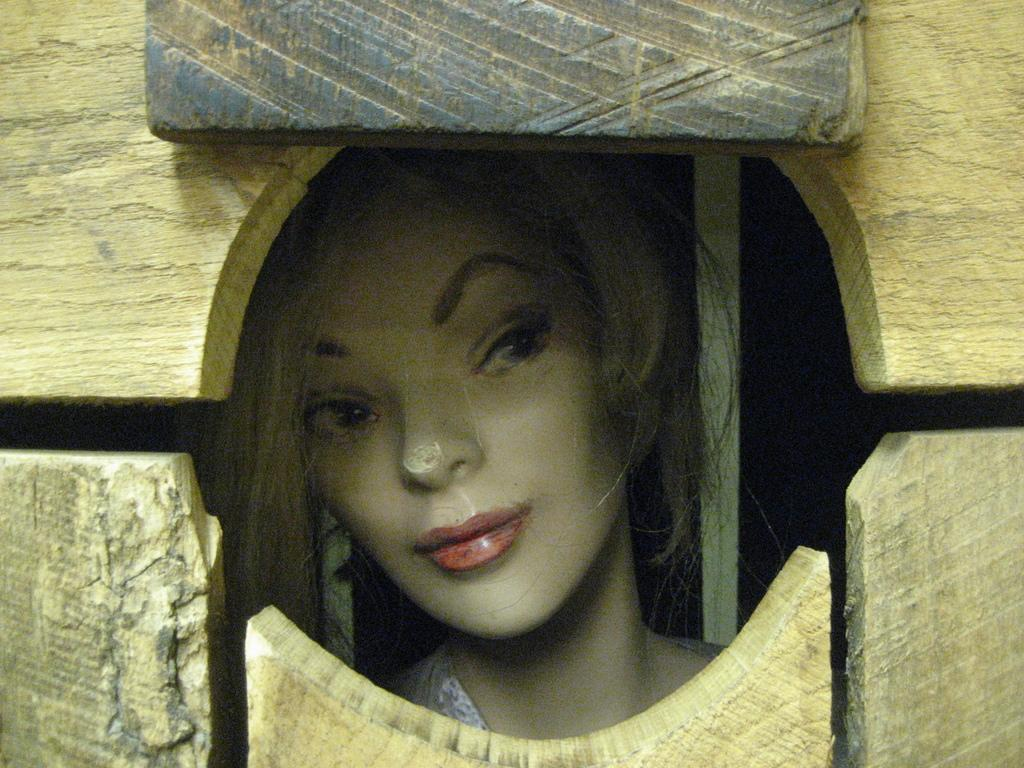What type of toy is present in the image? There is a female toy in the image. Can you describe the toy's surroundings? The female toy is in a wooden cage in the image. What type of bell can be heard ringing in the image? There is no bell present in the image, and therefore no sound can be heard. 